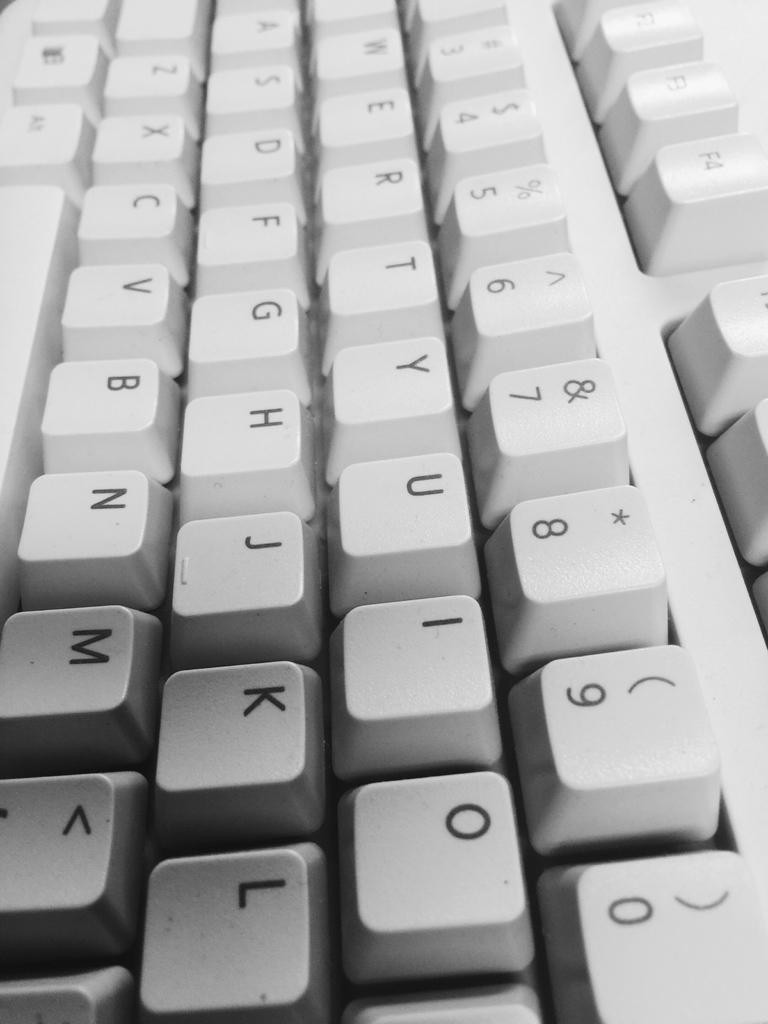<image>
Create a compact narrative representing the image presented. A white keyboard with all the letters and numbers prominently displayed. 